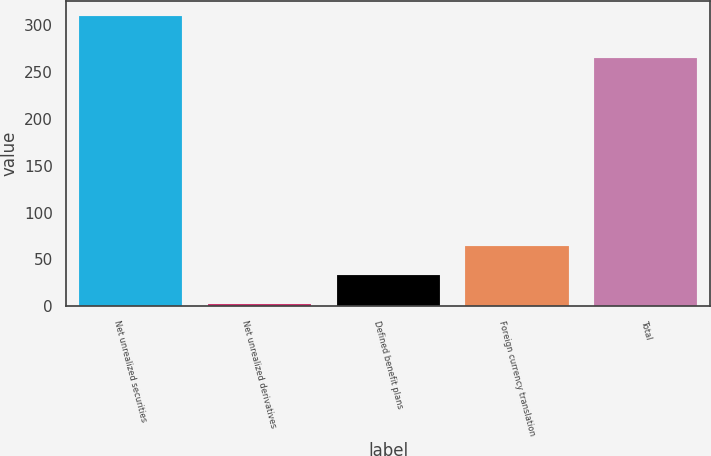Convert chart. <chart><loc_0><loc_0><loc_500><loc_500><bar_chart><fcel>Net unrealized securities<fcel>Net unrealized derivatives<fcel>Defined benefit plans<fcel>Foreign currency translation<fcel>Total<nl><fcel>310<fcel>3<fcel>33.7<fcel>64.4<fcel>265<nl></chart> 